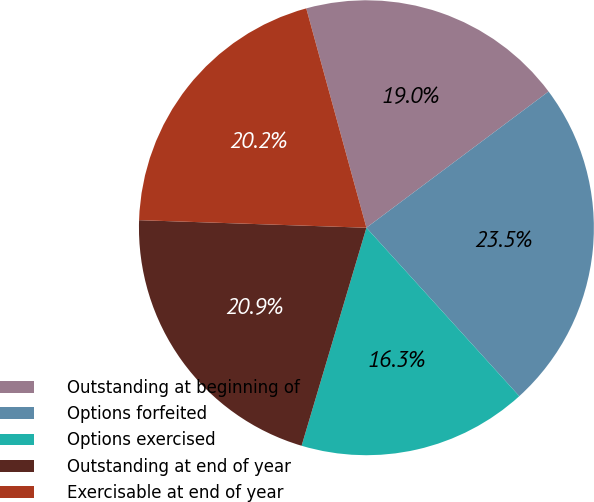Convert chart. <chart><loc_0><loc_0><loc_500><loc_500><pie_chart><fcel>Outstanding at beginning of<fcel>Options forfeited<fcel>Options exercised<fcel>Outstanding at end of year<fcel>Exercisable at end of year<nl><fcel>19.04%<fcel>23.49%<fcel>16.33%<fcel>20.93%<fcel>20.21%<nl></chart> 